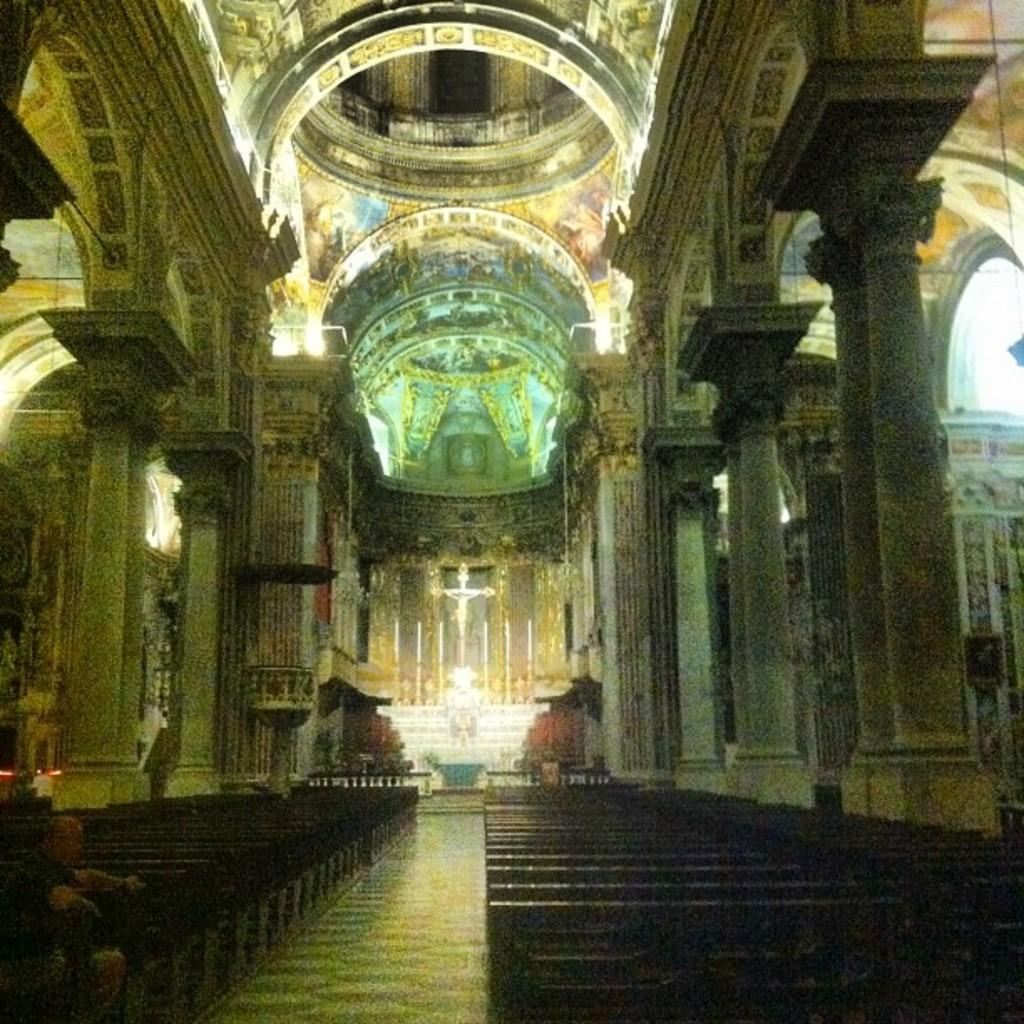What is the man in the image doing? The man is sitting on a bench in the image. Can you describe the man's position in relation to the bench? The man is sitting on the bench. What can be seen in front of the man? There are pillars, lights, and other unspecified things in front of the man. How does the man attempt to catch the falling twig in the image? There is no twig present in the image, and the man is not attempting to catch anything. 